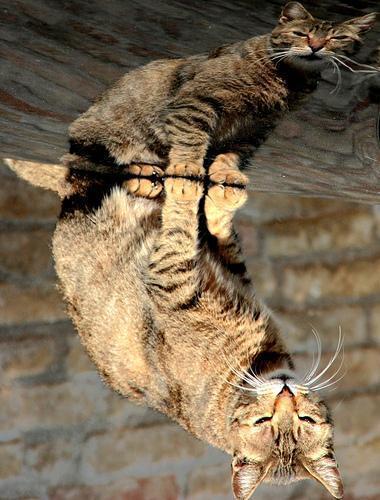How many cats are there?
Give a very brief answer. 1. How many animals are in the photo?
Give a very brief answer. 1. How many cats are in the photo?
Give a very brief answer. 2. 